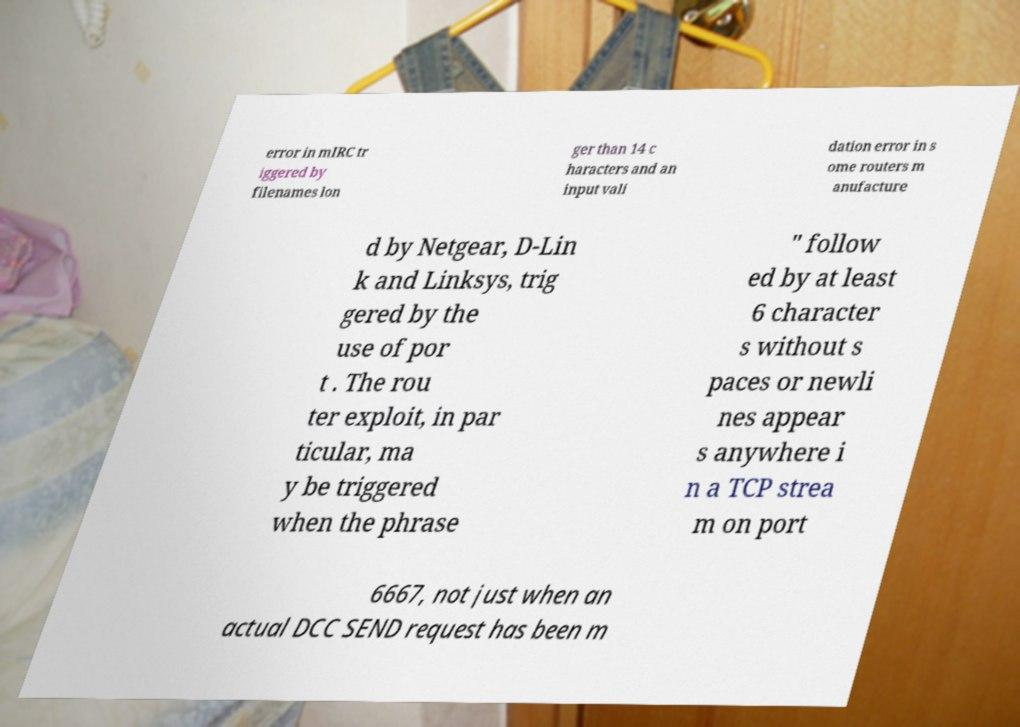There's text embedded in this image that I need extracted. Can you transcribe it verbatim? error in mIRC tr iggered by filenames lon ger than 14 c haracters and an input vali dation error in s ome routers m anufacture d by Netgear, D-Lin k and Linksys, trig gered by the use of por t . The rou ter exploit, in par ticular, ma y be triggered when the phrase " follow ed by at least 6 character s without s paces or newli nes appear s anywhere i n a TCP strea m on port 6667, not just when an actual DCC SEND request has been m 